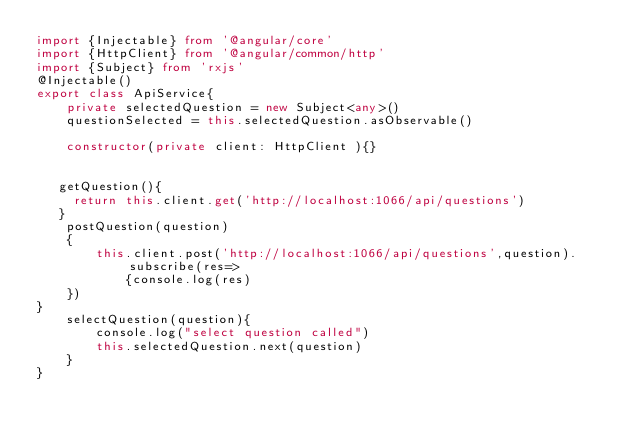<code> <loc_0><loc_0><loc_500><loc_500><_TypeScript_>import {Injectable} from '@angular/core'
import {HttpClient} from '@angular/common/http'
import {Subject} from 'rxjs'
@Injectable()
export class ApiService{
    private selectedQuestion = new Subject<any>()
    questionSelected = this.selectedQuestion.asObservable()   
    
    constructor(private client: HttpClient ){}

  
   getQuestion(){
     return this.client.get('http://localhost:1066/api/questions')
   }
    postQuestion(question)
    {
        this.client.post('http://localhost:1066/api/questions',question).subscribe(res=>
            {console.log(res)
    })
}
    selectQuestion(question){
        console.log("select question called")
        this.selectedQuestion.next(question)
    }
}

    
</code> 